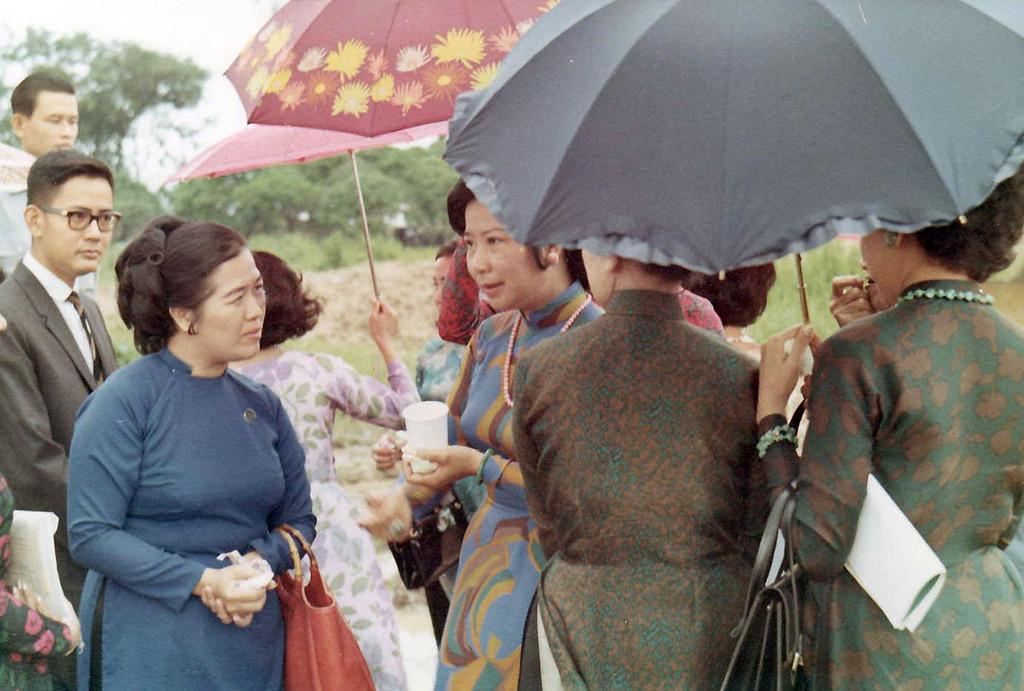How many people are present in the image? There are many people in the image. What are some people holding in the image? Some people are holding umbrellas and bags. What can be seen in the background of the image? There are trees in the background of the image. Can you describe the appearance of one person on the left side? One person on the left side is wearing glasses (specs). What type of lumber is being used to build a skirt in the image? There is no lumber or skirt present in the image. Can you tell me how the crook is interacting with the people in the image? There is no crook present in the image. 